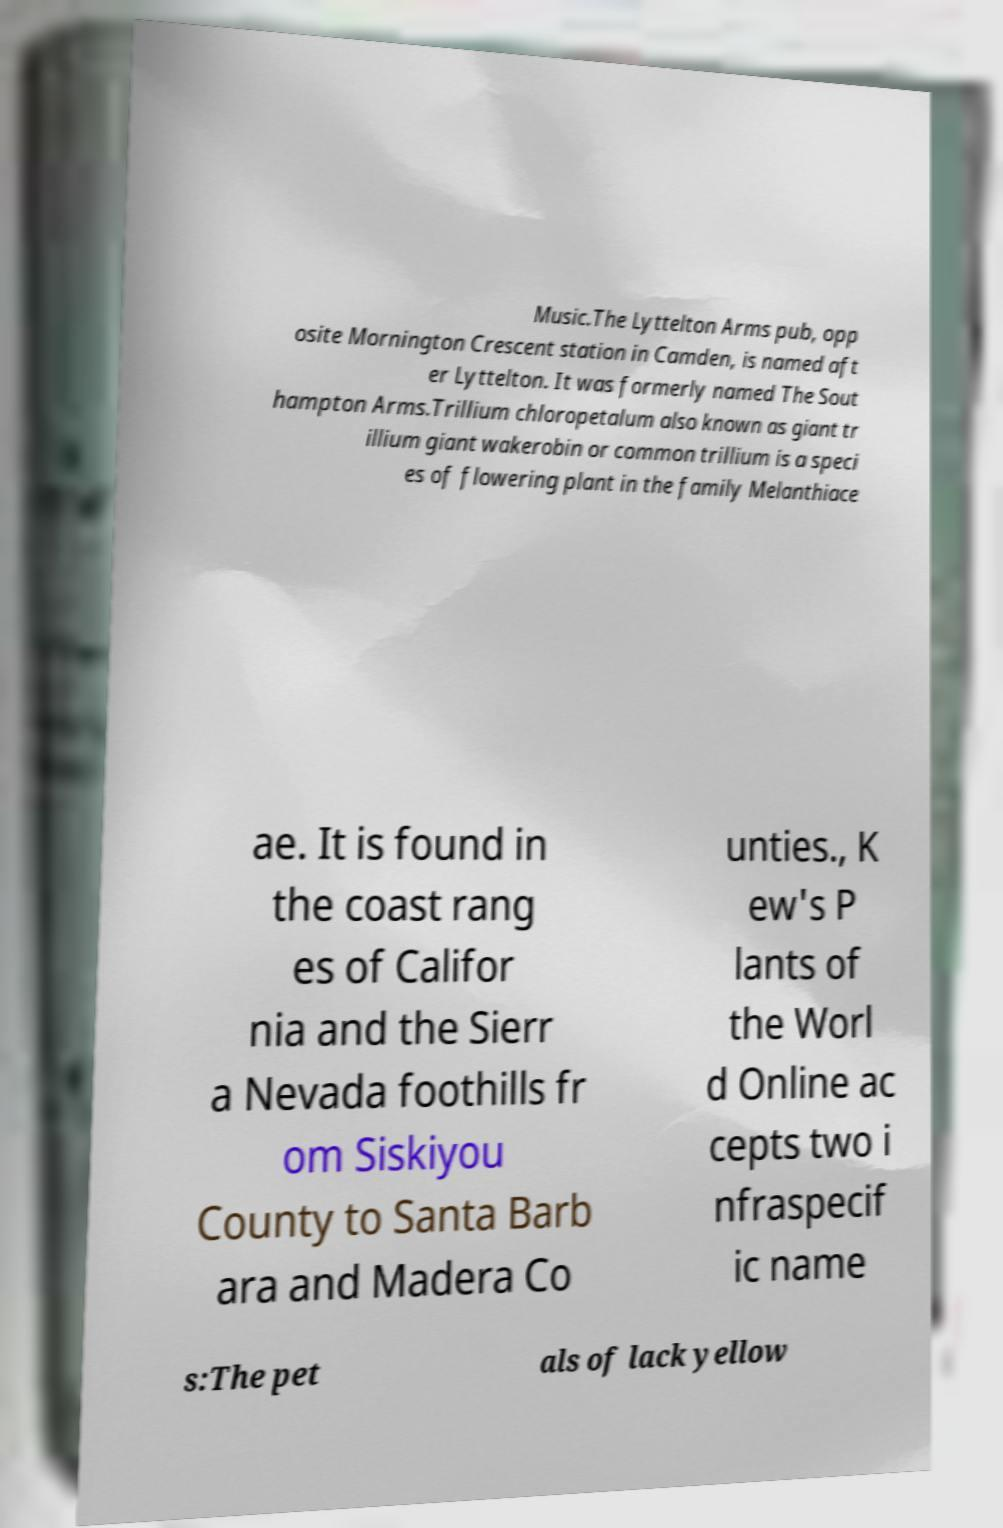Could you assist in decoding the text presented in this image and type it out clearly? Music.The Lyttelton Arms pub, opp osite Mornington Crescent station in Camden, is named aft er Lyttelton. It was formerly named The Sout hampton Arms.Trillium chloropetalum also known as giant tr illium giant wakerobin or common trillium is a speci es of flowering plant in the family Melanthiace ae. It is found in the coast rang es of Califor nia and the Sierr a Nevada foothills fr om Siskiyou County to Santa Barb ara and Madera Co unties., K ew's P lants of the Worl d Online ac cepts two i nfraspecif ic name s:The pet als of lack yellow 